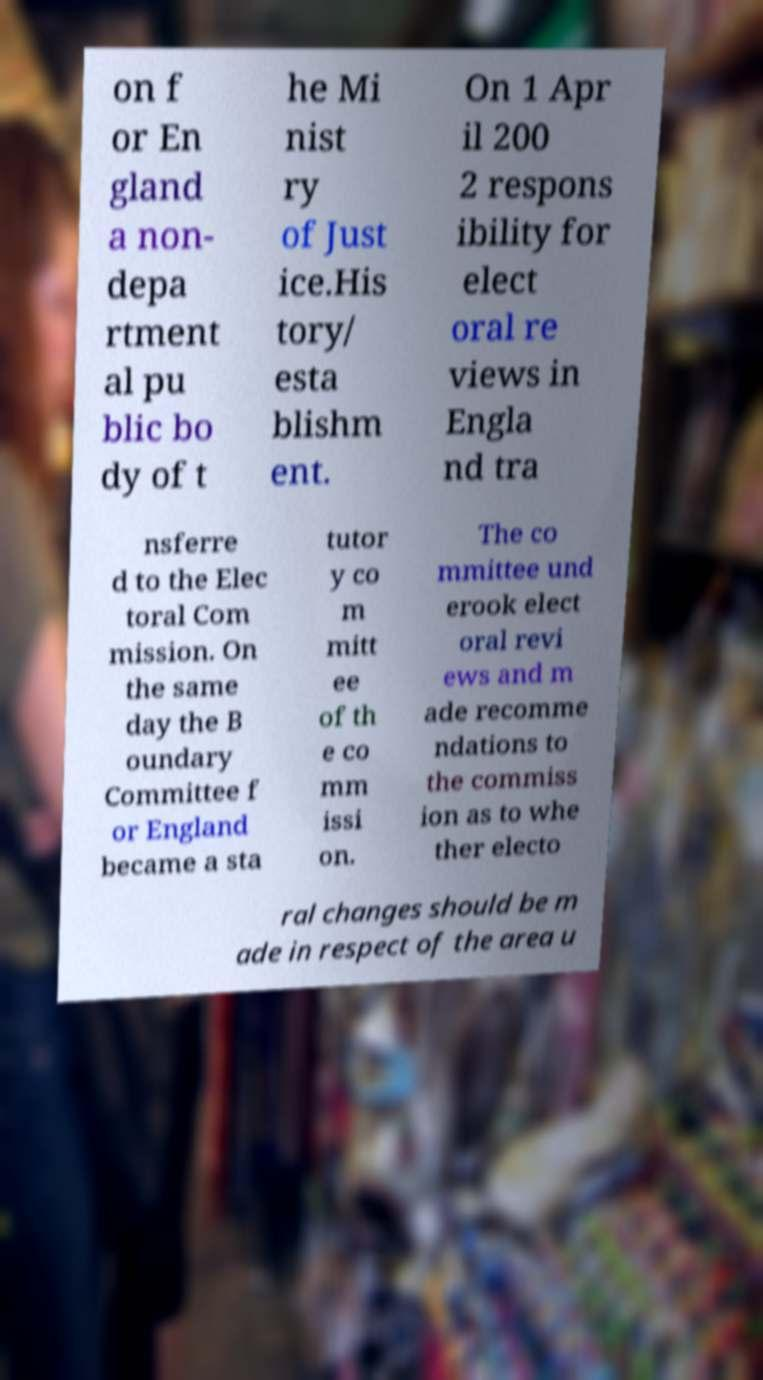I need the written content from this picture converted into text. Can you do that? on f or En gland a non- depa rtment al pu blic bo dy of t he Mi nist ry of Just ice.His tory/ esta blishm ent. On 1 Apr il 200 2 respons ibility for elect oral re views in Engla nd tra nsferre d to the Elec toral Com mission. On the same day the B oundary Committee f or England became a sta tutor y co m mitt ee of th e co mm issi on. The co mmittee und erook elect oral revi ews and m ade recomme ndations to the commiss ion as to whe ther electo ral changes should be m ade in respect of the area u 